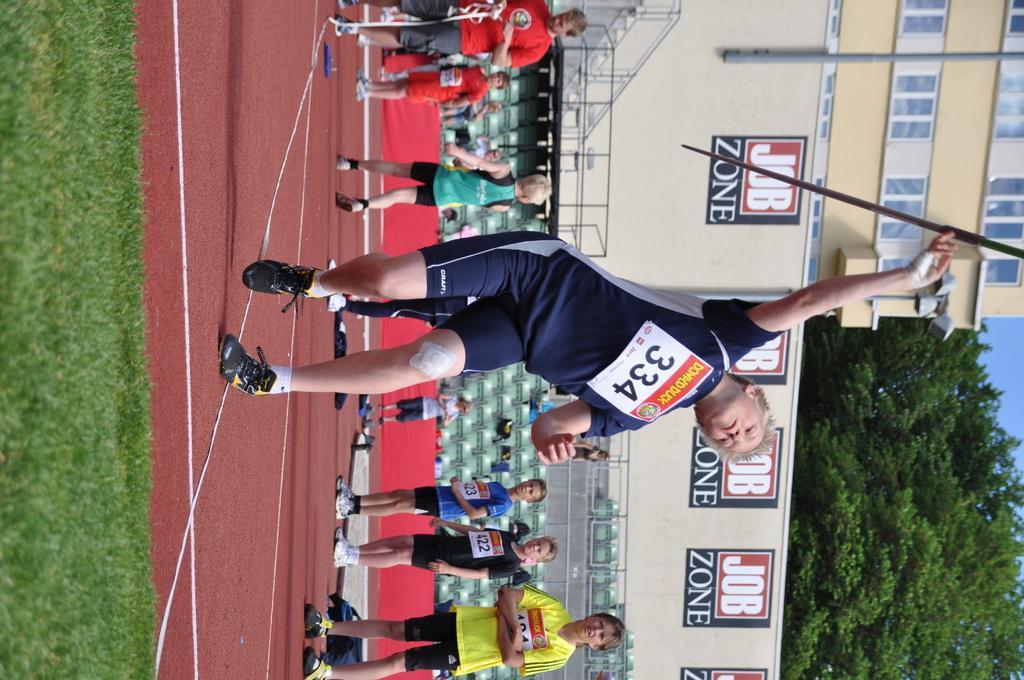In one or two sentences, can you explain what this image depicts? In the center of the picture there is a person throwing javelin throw. At the bottom there are people standing. On the left there is grass. On the right there are trees and building. In the center of the background there are persons playing and there is staircase, wall and boards. 